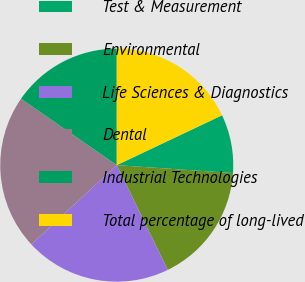<chart> <loc_0><loc_0><loc_500><loc_500><pie_chart><fcel>Test & Measurement<fcel>Environmental<fcel>Life Sciences & Diagnostics<fcel>Dental<fcel>Industrial Technologies<fcel>Total percentage of long-lived<nl><fcel>8.12%<fcel>16.7%<fcel>20.31%<fcel>21.57%<fcel>15.34%<fcel>17.96%<nl></chart> 